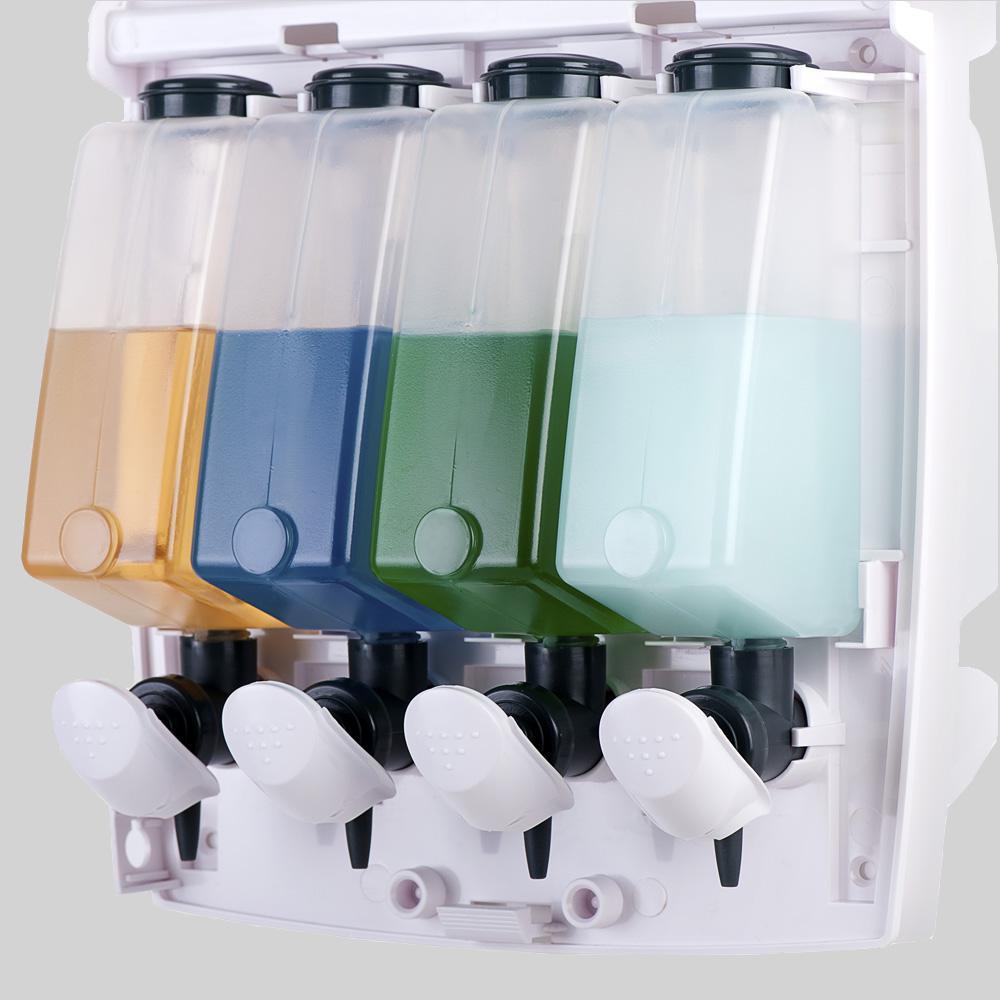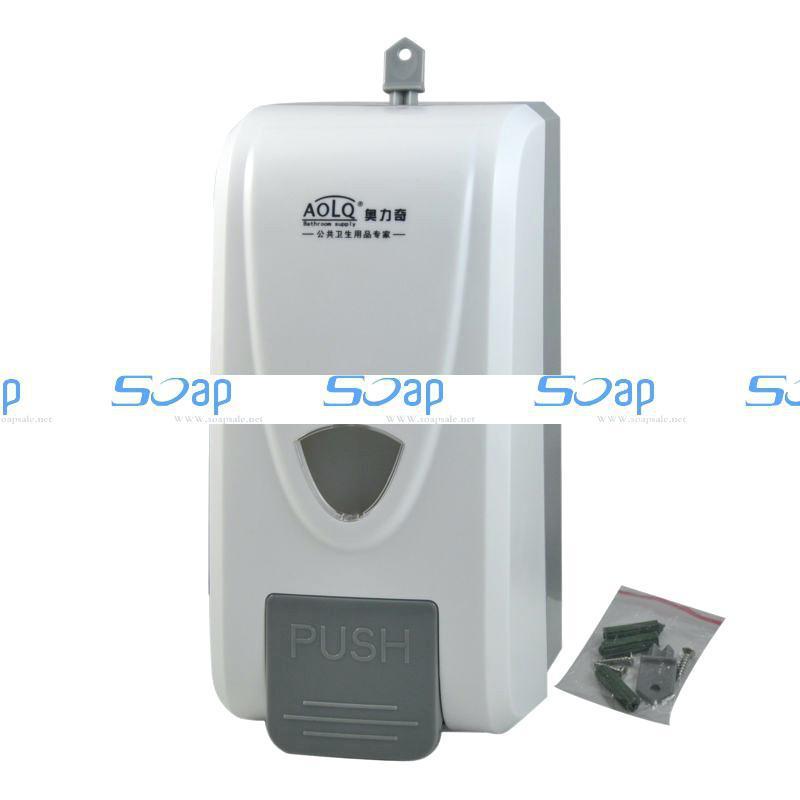The first image is the image on the left, the second image is the image on the right. Considering the images on both sides, is "The left and right image contains the same number of full wall hanging soap dispensers." valid? Answer yes or no. No. The first image is the image on the left, the second image is the image on the right. Given the left and right images, does the statement "One soap container is brown." hold true? Answer yes or no. No. 